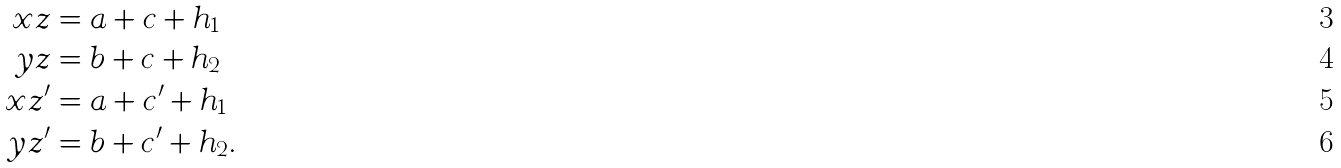<formula> <loc_0><loc_0><loc_500><loc_500>x z & = a + c + h _ { 1 } \\ y z & = b + c + h _ { 2 } \\ x z ^ { \prime } & = a + c ^ { \prime } + h _ { 1 } \\ y z ^ { \prime } & = b + c ^ { \prime } + h _ { 2 } .</formula> 